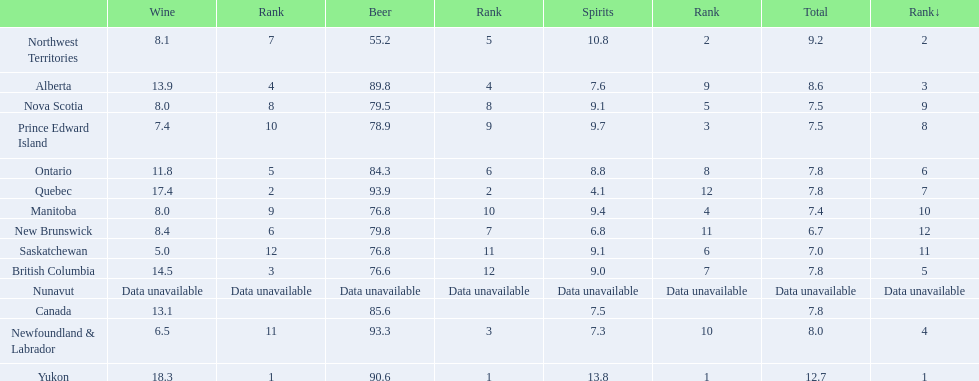What are all the canadian regions? Yukon, Northwest Territories, Alberta, Newfoundland & Labrador, British Columbia, Ontario, Quebec, Prince Edward Island, Nova Scotia, Manitoba, Saskatchewan, New Brunswick, Nunavut, Canada. What was the spirits consumption? 13.8, 10.8, 7.6, 7.3, 9.0, 8.8, 4.1, 9.7, 9.1, 9.4, 9.1, 6.8, Data unavailable, 7.5. What was quebec's spirit consumption? 4.1. 